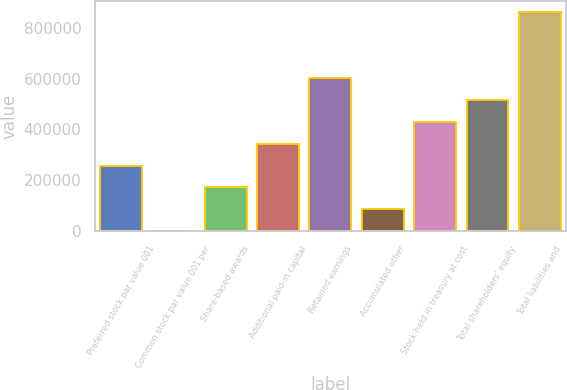Convert chart to OTSL. <chart><loc_0><loc_0><loc_500><loc_500><bar_chart><fcel>Preferred stock par value 001<fcel>Common stock par value 001 per<fcel>Share-based awards<fcel>Additional paid-in capital<fcel>Retained earnings<fcel>Accumulated other<fcel>Stock held in treasury at cost<fcel>Total shareholders' equity<fcel>Total liabilities and<nl><fcel>258056<fcel>9<fcel>172040<fcel>344071<fcel>602118<fcel>86024.6<fcel>430087<fcel>516103<fcel>860165<nl></chart> 